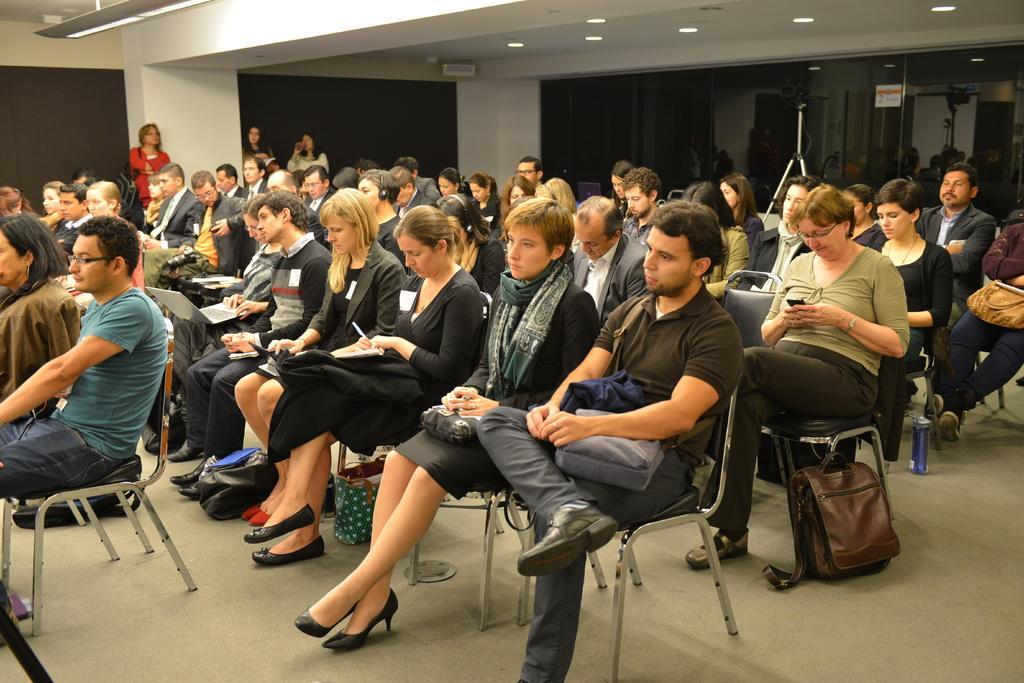Please provide a concise description of this image. This is an inside view of a room. Here I can see a crowd of people sitting on the chairs facing towards the left side. There are few bags placed on the floor. In the background three women are standing and also I can see two pillars. On the right side there are few metal stands. At the top there are few lights. 